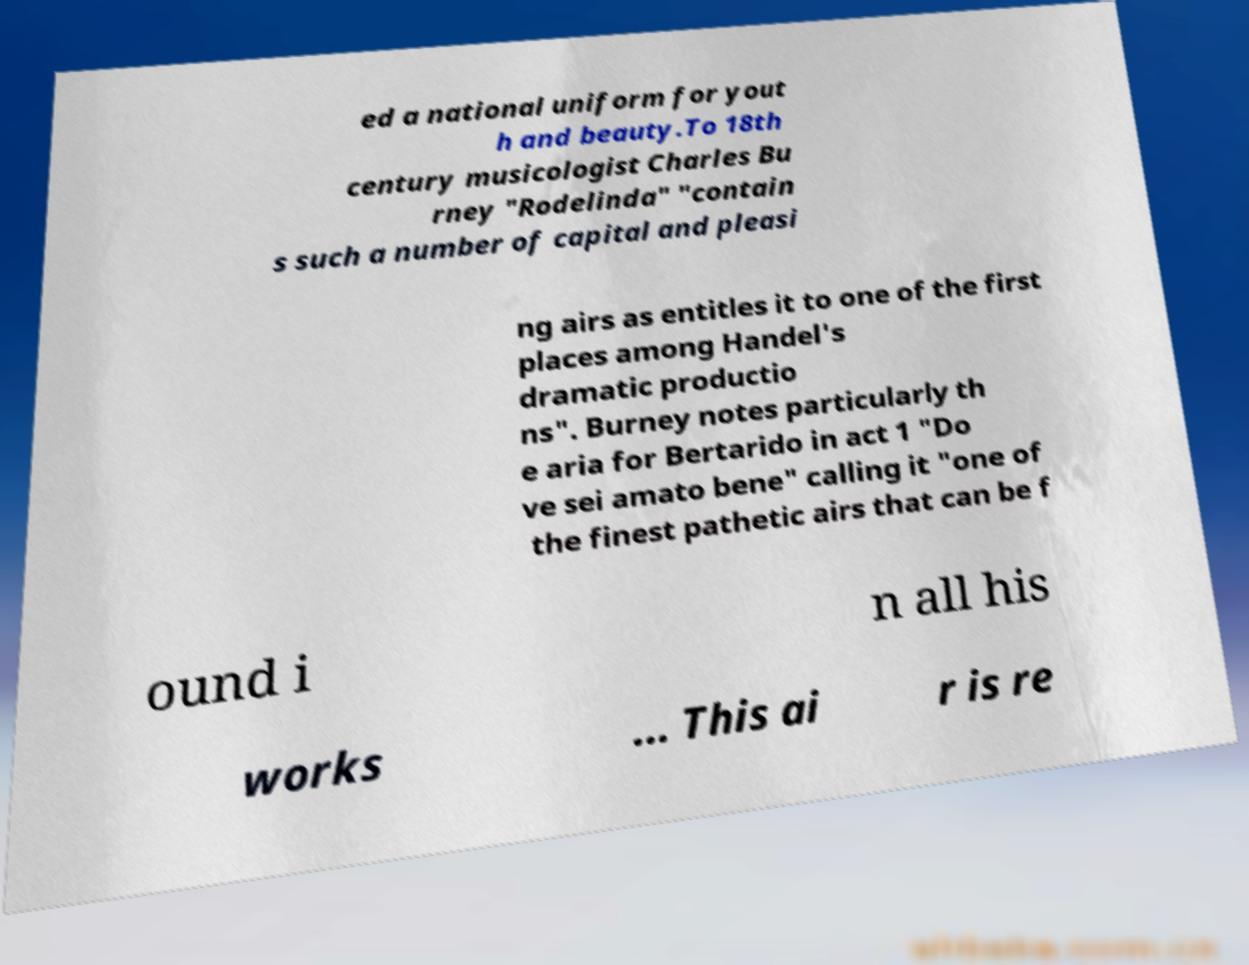Could you extract and type out the text from this image? ed a national uniform for yout h and beauty.To 18th century musicologist Charles Bu rney "Rodelinda" "contain s such a number of capital and pleasi ng airs as entitles it to one of the first places among Handel's dramatic productio ns". Burney notes particularly th e aria for Bertarido in act 1 "Do ve sei amato bene" calling it "one of the finest pathetic airs that can be f ound i n all his works ... This ai r is re 